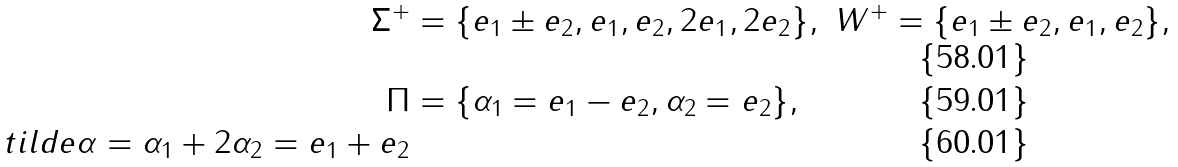<formula> <loc_0><loc_0><loc_500><loc_500>\Sigma ^ { + } & = \{ e _ { 1 } \pm e _ { 2 } , e _ { 1 } , e _ { 2 } , 2 e _ { 1 } , 2 e _ { 2 } \} , \ W ^ { + } = \{ e _ { 1 } \pm e _ { 2 } , e _ { 1 } , e _ { 2 } \} , \\ \Pi & = \{ \alpha _ { 1 } = e _ { 1 } - e _ { 2 } , \alpha _ { 2 } = e _ { 2 } \} , \\ t i l d e { \alpha } = \alpha _ { 1 } + 2 \alpha _ { 2 } = e _ { 1 } + e _ { 2 }</formula> 